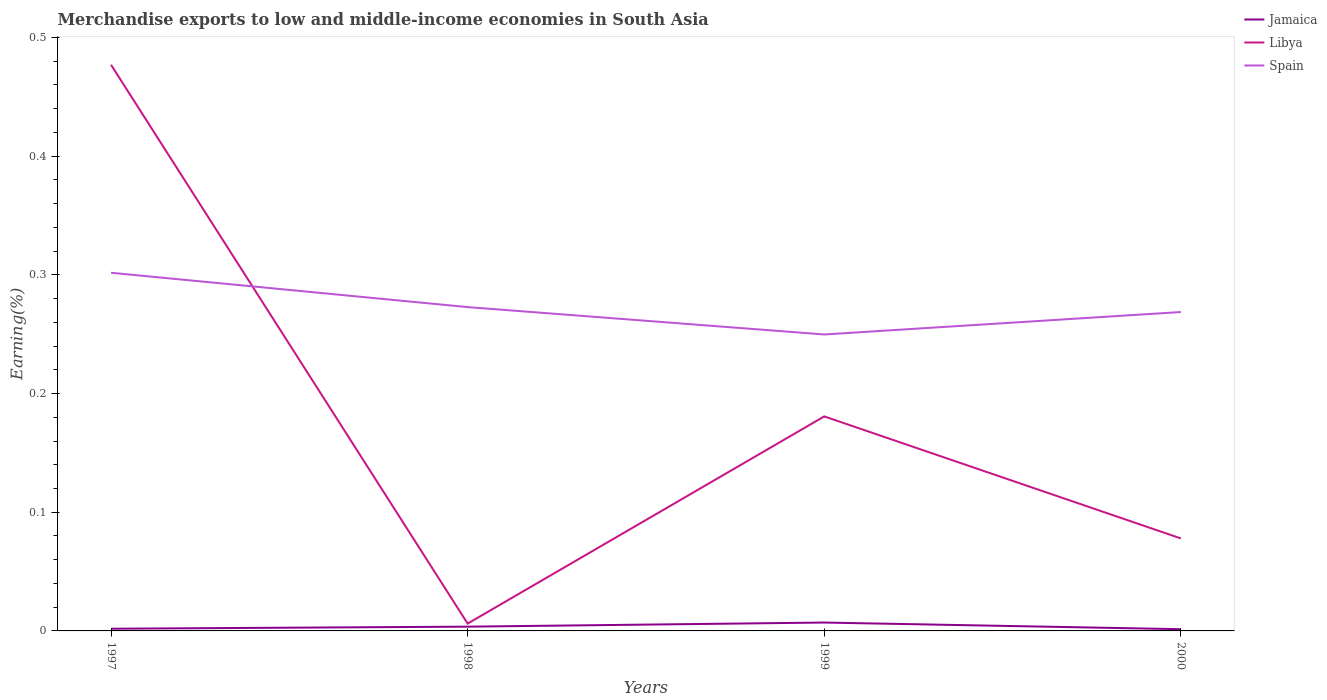How many different coloured lines are there?
Your response must be concise. 3. Does the line corresponding to Jamaica intersect with the line corresponding to Spain?
Ensure brevity in your answer.  No. Is the number of lines equal to the number of legend labels?
Your answer should be compact. Yes. Across all years, what is the maximum percentage of amount earned from merchandise exports in Jamaica?
Keep it short and to the point. 0. In which year was the percentage of amount earned from merchandise exports in Libya maximum?
Make the answer very short. 1998. What is the total percentage of amount earned from merchandise exports in Spain in the graph?
Give a very brief answer. 0.03. What is the difference between the highest and the second highest percentage of amount earned from merchandise exports in Libya?
Keep it short and to the point. 0.47. What is the difference between the highest and the lowest percentage of amount earned from merchandise exports in Spain?
Keep it short and to the point. 1. Is the percentage of amount earned from merchandise exports in Jamaica strictly greater than the percentage of amount earned from merchandise exports in Libya over the years?
Provide a short and direct response. Yes. How many years are there in the graph?
Give a very brief answer. 4. What is the difference between two consecutive major ticks on the Y-axis?
Offer a very short reply. 0.1. How many legend labels are there?
Make the answer very short. 3. How are the legend labels stacked?
Make the answer very short. Vertical. What is the title of the graph?
Provide a short and direct response. Merchandise exports to low and middle-income economies in South Asia. Does "Madagascar" appear as one of the legend labels in the graph?
Provide a short and direct response. No. What is the label or title of the X-axis?
Give a very brief answer. Years. What is the label or title of the Y-axis?
Offer a very short reply. Earning(%). What is the Earning(%) of Jamaica in 1997?
Offer a terse response. 0. What is the Earning(%) in Libya in 1997?
Provide a succinct answer. 0.48. What is the Earning(%) in Spain in 1997?
Offer a terse response. 0.3. What is the Earning(%) of Jamaica in 1998?
Provide a succinct answer. 0. What is the Earning(%) in Libya in 1998?
Provide a short and direct response. 0.01. What is the Earning(%) of Spain in 1998?
Your answer should be very brief. 0.27. What is the Earning(%) in Jamaica in 1999?
Offer a very short reply. 0.01. What is the Earning(%) in Libya in 1999?
Your answer should be very brief. 0.18. What is the Earning(%) of Spain in 1999?
Keep it short and to the point. 0.25. What is the Earning(%) in Jamaica in 2000?
Make the answer very short. 0. What is the Earning(%) of Libya in 2000?
Make the answer very short. 0.08. What is the Earning(%) in Spain in 2000?
Ensure brevity in your answer.  0.27. Across all years, what is the maximum Earning(%) of Jamaica?
Offer a terse response. 0.01. Across all years, what is the maximum Earning(%) of Libya?
Your answer should be very brief. 0.48. Across all years, what is the maximum Earning(%) in Spain?
Offer a very short reply. 0.3. Across all years, what is the minimum Earning(%) of Jamaica?
Ensure brevity in your answer.  0. Across all years, what is the minimum Earning(%) in Libya?
Provide a succinct answer. 0.01. Across all years, what is the minimum Earning(%) of Spain?
Make the answer very short. 0.25. What is the total Earning(%) in Jamaica in the graph?
Provide a short and direct response. 0.01. What is the total Earning(%) in Libya in the graph?
Make the answer very short. 0.74. What is the total Earning(%) in Spain in the graph?
Your answer should be very brief. 1.09. What is the difference between the Earning(%) in Jamaica in 1997 and that in 1998?
Your answer should be compact. -0. What is the difference between the Earning(%) of Libya in 1997 and that in 1998?
Offer a very short reply. 0.47. What is the difference between the Earning(%) of Spain in 1997 and that in 1998?
Offer a very short reply. 0.03. What is the difference between the Earning(%) in Jamaica in 1997 and that in 1999?
Offer a very short reply. -0.01. What is the difference between the Earning(%) of Libya in 1997 and that in 1999?
Provide a succinct answer. 0.3. What is the difference between the Earning(%) of Spain in 1997 and that in 1999?
Your response must be concise. 0.05. What is the difference between the Earning(%) in Libya in 1997 and that in 2000?
Your answer should be very brief. 0.4. What is the difference between the Earning(%) in Spain in 1997 and that in 2000?
Offer a very short reply. 0.03. What is the difference between the Earning(%) in Jamaica in 1998 and that in 1999?
Your answer should be compact. -0. What is the difference between the Earning(%) in Libya in 1998 and that in 1999?
Offer a terse response. -0.17. What is the difference between the Earning(%) of Spain in 1998 and that in 1999?
Your response must be concise. 0.02. What is the difference between the Earning(%) of Jamaica in 1998 and that in 2000?
Your answer should be very brief. 0. What is the difference between the Earning(%) in Libya in 1998 and that in 2000?
Give a very brief answer. -0.07. What is the difference between the Earning(%) in Spain in 1998 and that in 2000?
Make the answer very short. 0. What is the difference between the Earning(%) of Jamaica in 1999 and that in 2000?
Your answer should be very brief. 0.01. What is the difference between the Earning(%) of Libya in 1999 and that in 2000?
Provide a succinct answer. 0.1. What is the difference between the Earning(%) of Spain in 1999 and that in 2000?
Your answer should be very brief. -0.02. What is the difference between the Earning(%) in Jamaica in 1997 and the Earning(%) in Libya in 1998?
Keep it short and to the point. -0. What is the difference between the Earning(%) in Jamaica in 1997 and the Earning(%) in Spain in 1998?
Ensure brevity in your answer.  -0.27. What is the difference between the Earning(%) in Libya in 1997 and the Earning(%) in Spain in 1998?
Keep it short and to the point. 0.2. What is the difference between the Earning(%) of Jamaica in 1997 and the Earning(%) of Libya in 1999?
Your response must be concise. -0.18. What is the difference between the Earning(%) of Jamaica in 1997 and the Earning(%) of Spain in 1999?
Your answer should be very brief. -0.25. What is the difference between the Earning(%) of Libya in 1997 and the Earning(%) of Spain in 1999?
Give a very brief answer. 0.23. What is the difference between the Earning(%) of Jamaica in 1997 and the Earning(%) of Libya in 2000?
Provide a succinct answer. -0.08. What is the difference between the Earning(%) in Jamaica in 1997 and the Earning(%) in Spain in 2000?
Keep it short and to the point. -0.27. What is the difference between the Earning(%) in Libya in 1997 and the Earning(%) in Spain in 2000?
Your response must be concise. 0.21. What is the difference between the Earning(%) of Jamaica in 1998 and the Earning(%) of Libya in 1999?
Offer a very short reply. -0.18. What is the difference between the Earning(%) in Jamaica in 1998 and the Earning(%) in Spain in 1999?
Your response must be concise. -0.25. What is the difference between the Earning(%) of Libya in 1998 and the Earning(%) of Spain in 1999?
Ensure brevity in your answer.  -0.24. What is the difference between the Earning(%) of Jamaica in 1998 and the Earning(%) of Libya in 2000?
Your answer should be compact. -0.07. What is the difference between the Earning(%) of Jamaica in 1998 and the Earning(%) of Spain in 2000?
Your answer should be compact. -0.27. What is the difference between the Earning(%) in Libya in 1998 and the Earning(%) in Spain in 2000?
Provide a succinct answer. -0.26. What is the difference between the Earning(%) in Jamaica in 1999 and the Earning(%) in Libya in 2000?
Keep it short and to the point. -0.07. What is the difference between the Earning(%) of Jamaica in 1999 and the Earning(%) of Spain in 2000?
Offer a terse response. -0.26. What is the difference between the Earning(%) of Libya in 1999 and the Earning(%) of Spain in 2000?
Offer a very short reply. -0.09. What is the average Earning(%) of Jamaica per year?
Give a very brief answer. 0. What is the average Earning(%) of Libya per year?
Provide a succinct answer. 0.19. What is the average Earning(%) in Spain per year?
Ensure brevity in your answer.  0.27. In the year 1997, what is the difference between the Earning(%) in Jamaica and Earning(%) in Libya?
Provide a short and direct response. -0.48. In the year 1997, what is the difference between the Earning(%) in Jamaica and Earning(%) in Spain?
Keep it short and to the point. -0.3. In the year 1997, what is the difference between the Earning(%) in Libya and Earning(%) in Spain?
Your answer should be compact. 0.18. In the year 1998, what is the difference between the Earning(%) of Jamaica and Earning(%) of Libya?
Ensure brevity in your answer.  -0. In the year 1998, what is the difference between the Earning(%) in Jamaica and Earning(%) in Spain?
Your answer should be compact. -0.27. In the year 1998, what is the difference between the Earning(%) of Libya and Earning(%) of Spain?
Your answer should be very brief. -0.27. In the year 1999, what is the difference between the Earning(%) in Jamaica and Earning(%) in Libya?
Keep it short and to the point. -0.17. In the year 1999, what is the difference between the Earning(%) of Jamaica and Earning(%) of Spain?
Make the answer very short. -0.24. In the year 1999, what is the difference between the Earning(%) of Libya and Earning(%) of Spain?
Your answer should be very brief. -0.07. In the year 2000, what is the difference between the Earning(%) in Jamaica and Earning(%) in Libya?
Your response must be concise. -0.08. In the year 2000, what is the difference between the Earning(%) of Jamaica and Earning(%) of Spain?
Keep it short and to the point. -0.27. In the year 2000, what is the difference between the Earning(%) in Libya and Earning(%) in Spain?
Provide a succinct answer. -0.19. What is the ratio of the Earning(%) in Jamaica in 1997 to that in 1998?
Make the answer very short. 0.51. What is the ratio of the Earning(%) of Libya in 1997 to that in 1998?
Ensure brevity in your answer.  77.18. What is the ratio of the Earning(%) in Spain in 1997 to that in 1998?
Offer a very short reply. 1.11. What is the ratio of the Earning(%) in Jamaica in 1997 to that in 1999?
Your answer should be compact. 0.26. What is the ratio of the Earning(%) of Libya in 1997 to that in 1999?
Ensure brevity in your answer.  2.64. What is the ratio of the Earning(%) of Spain in 1997 to that in 1999?
Keep it short and to the point. 1.21. What is the ratio of the Earning(%) in Jamaica in 1997 to that in 2000?
Provide a succinct answer. 1.26. What is the ratio of the Earning(%) in Libya in 1997 to that in 2000?
Give a very brief answer. 6.12. What is the ratio of the Earning(%) of Spain in 1997 to that in 2000?
Offer a very short reply. 1.12. What is the ratio of the Earning(%) in Jamaica in 1998 to that in 1999?
Your answer should be compact. 0.51. What is the ratio of the Earning(%) of Libya in 1998 to that in 1999?
Offer a very short reply. 0.03. What is the ratio of the Earning(%) in Spain in 1998 to that in 1999?
Make the answer very short. 1.09. What is the ratio of the Earning(%) in Jamaica in 1998 to that in 2000?
Your answer should be very brief. 2.45. What is the ratio of the Earning(%) of Libya in 1998 to that in 2000?
Offer a very short reply. 0.08. What is the ratio of the Earning(%) in Spain in 1998 to that in 2000?
Provide a short and direct response. 1.02. What is the ratio of the Earning(%) of Jamaica in 1999 to that in 2000?
Your response must be concise. 4.82. What is the ratio of the Earning(%) of Libya in 1999 to that in 2000?
Provide a succinct answer. 2.32. What is the ratio of the Earning(%) in Spain in 1999 to that in 2000?
Keep it short and to the point. 0.93. What is the difference between the highest and the second highest Earning(%) in Jamaica?
Ensure brevity in your answer.  0. What is the difference between the highest and the second highest Earning(%) in Libya?
Your answer should be very brief. 0.3. What is the difference between the highest and the second highest Earning(%) of Spain?
Ensure brevity in your answer.  0.03. What is the difference between the highest and the lowest Earning(%) in Jamaica?
Keep it short and to the point. 0.01. What is the difference between the highest and the lowest Earning(%) of Libya?
Provide a short and direct response. 0.47. What is the difference between the highest and the lowest Earning(%) in Spain?
Your response must be concise. 0.05. 